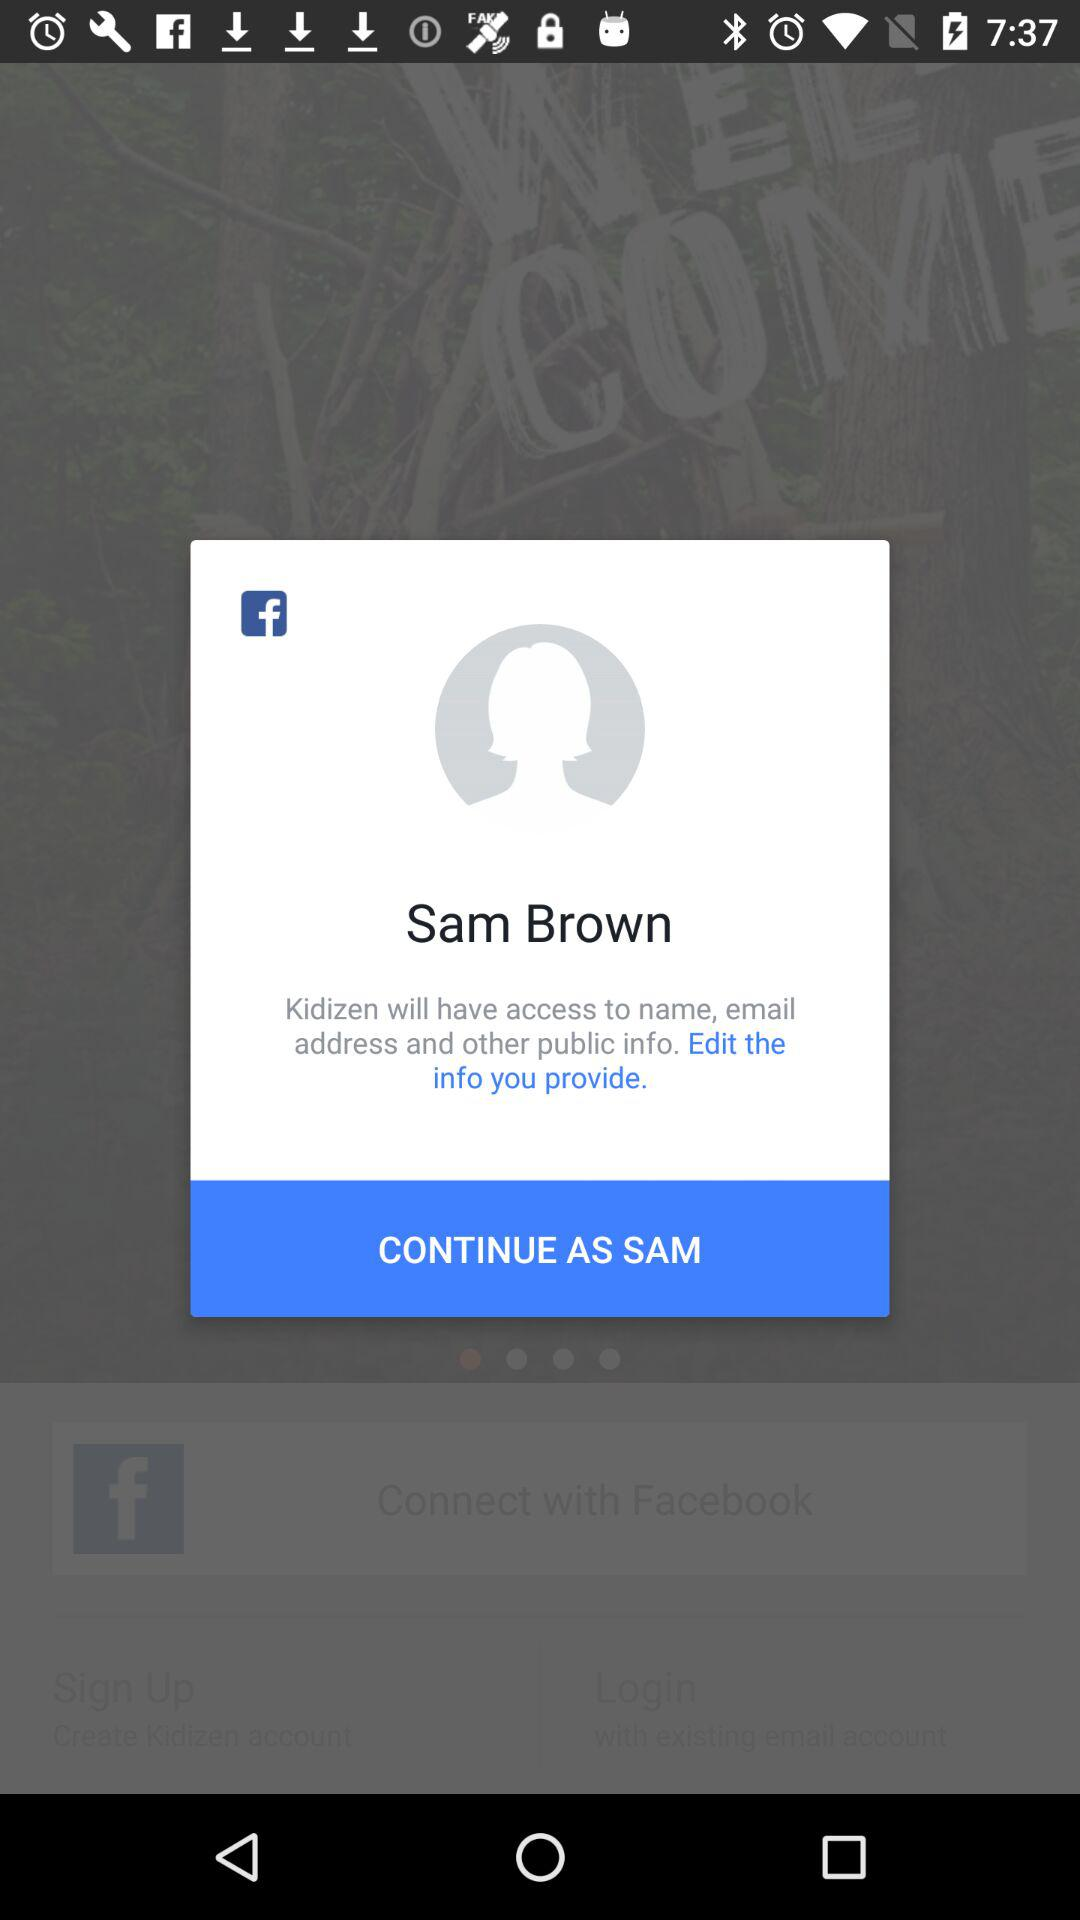What is the name of the user? The name of the user is Sam Brown. 